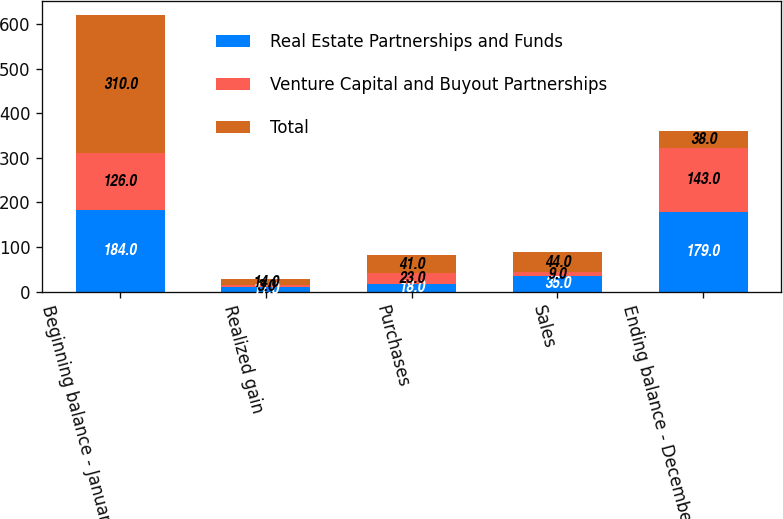Convert chart. <chart><loc_0><loc_0><loc_500><loc_500><stacked_bar_chart><ecel><fcel>Beginning balance - January 1<fcel>Realized gain<fcel>Purchases<fcel>Sales<fcel>Ending balance - December 31<nl><fcel>Real Estate Partnerships and Funds<fcel>184<fcel>11<fcel>18<fcel>35<fcel>179<nl><fcel>Venture Capital and Buyout Partnerships<fcel>126<fcel>3<fcel>23<fcel>9<fcel>143<nl><fcel>Total<fcel>310<fcel>14<fcel>41<fcel>44<fcel>38<nl></chart> 